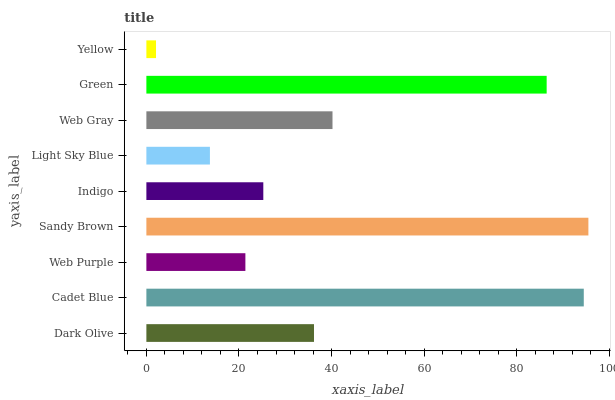Is Yellow the minimum?
Answer yes or no. Yes. Is Sandy Brown the maximum?
Answer yes or no. Yes. Is Cadet Blue the minimum?
Answer yes or no. No. Is Cadet Blue the maximum?
Answer yes or no. No. Is Cadet Blue greater than Dark Olive?
Answer yes or no. Yes. Is Dark Olive less than Cadet Blue?
Answer yes or no. Yes. Is Dark Olive greater than Cadet Blue?
Answer yes or no. No. Is Cadet Blue less than Dark Olive?
Answer yes or no. No. Is Dark Olive the high median?
Answer yes or no. Yes. Is Dark Olive the low median?
Answer yes or no. Yes. Is Web Gray the high median?
Answer yes or no. No. Is Web Gray the low median?
Answer yes or no. No. 